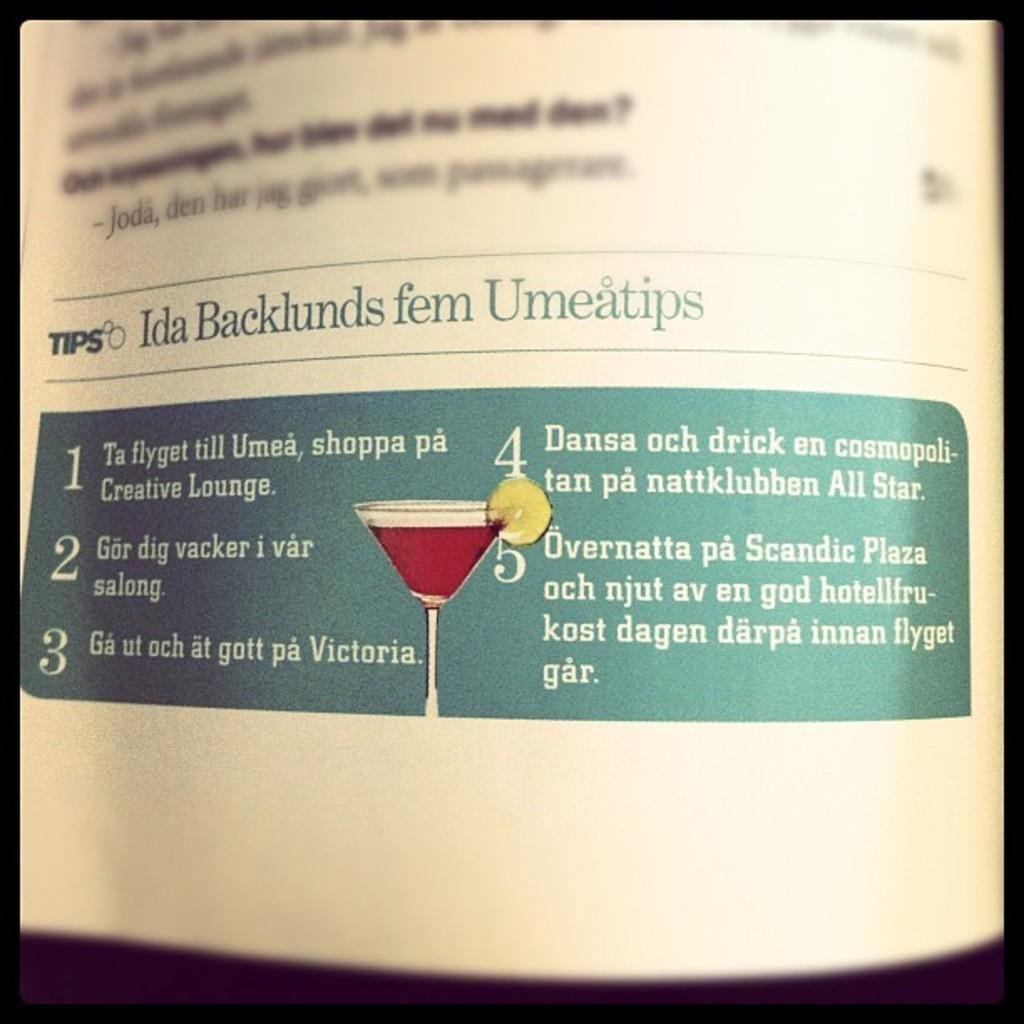Provide a one-sentence caption for the provided image. Ida Backlunds fem Umeatips banner on a magazine. 